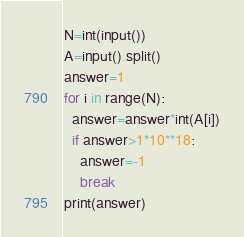<code> <loc_0><loc_0><loc_500><loc_500><_Python_>N=int(input())
A=input().split()
answer=1
for i in range(N):
  answer=answer*int(A[i])
  if answer>1*10**18:
    answer=-1
    break
print(answer)</code> 